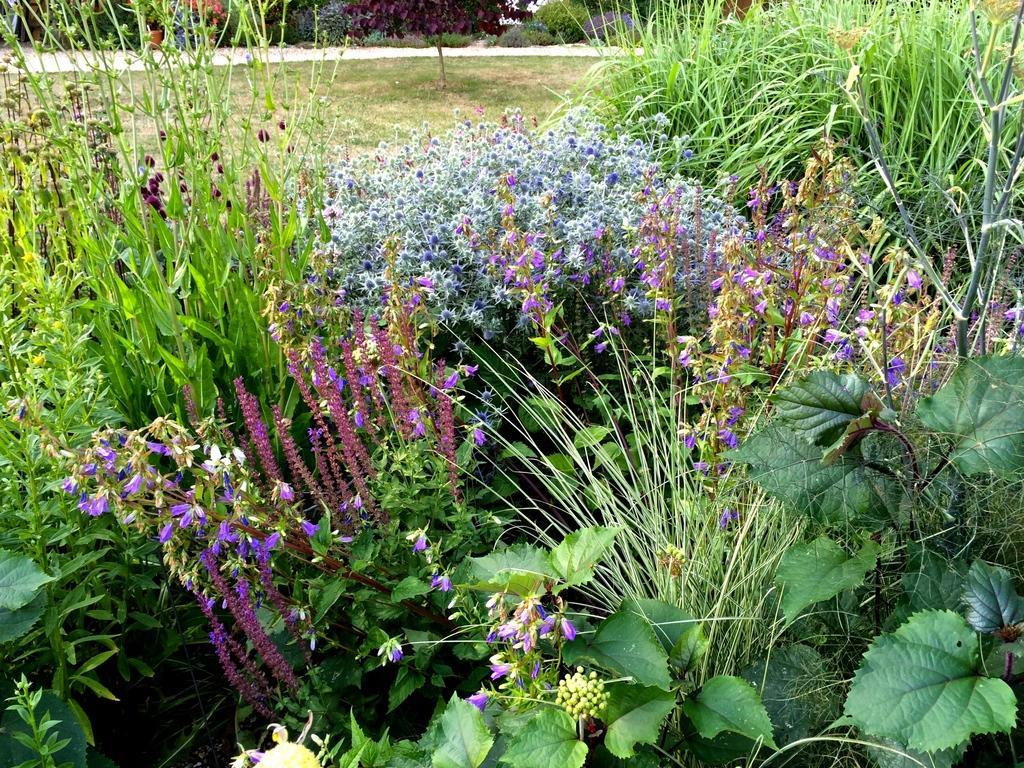In one or two sentences, can you explain what this image depicts? It is a zoom in picture of many plants and also grass. In the background we can also see some trees. 